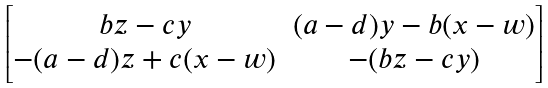<formula> <loc_0><loc_0><loc_500><loc_500>\begin{bmatrix} b z - c y & ( a - d ) y - b ( x - w ) \\ - ( a - d ) z + c ( x - w ) & - ( b z - c y ) \end{bmatrix}</formula> 